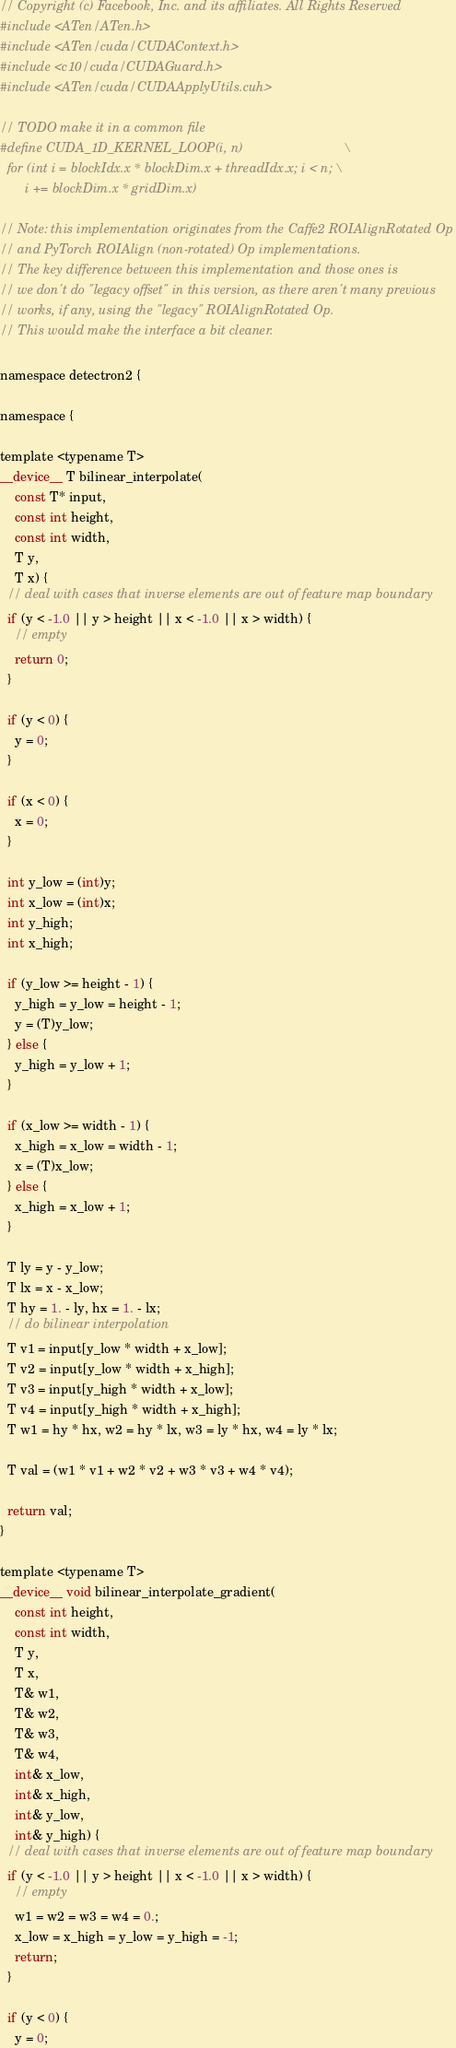Convert code to text. <code><loc_0><loc_0><loc_500><loc_500><_Cuda_>// Copyright (c) Facebook, Inc. and its affiliates. All Rights Reserved
#include <ATen/ATen.h>
#include <ATen/cuda/CUDAContext.h>
#include <c10/cuda/CUDAGuard.h>
#include <ATen/cuda/CUDAApplyUtils.cuh>

// TODO make it in a common file
#define CUDA_1D_KERNEL_LOOP(i, n)                            \
  for (int i = blockIdx.x * blockDim.x + threadIdx.x; i < n; \
       i += blockDim.x * gridDim.x)

// Note: this implementation originates from the Caffe2 ROIAlignRotated Op
// and PyTorch ROIAlign (non-rotated) Op implementations.
// The key difference between this implementation and those ones is
// we don't do "legacy offset" in this version, as there aren't many previous
// works, if any, using the "legacy" ROIAlignRotated Op.
// This would make the interface a bit cleaner.

namespace detectron2 {

namespace {

template <typename T>
__device__ T bilinear_interpolate(
    const T* input,
    const int height,
    const int width,
    T y,
    T x) {
  // deal with cases that inverse elements are out of feature map boundary
  if (y < -1.0 || y > height || x < -1.0 || x > width) {
    // empty
    return 0;
  }

  if (y < 0) {
    y = 0;
  }

  if (x < 0) {
    x = 0;
  }

  int y_low = (int)y;
  int x_low = (int)x;
  int y_high;
  int x_high;

  if (y_low >= height - 1) {
    y_high = y_low = height - 1;
    y = (T)y_low;
  } else {
    y_high = y_low + 1;
  }

  if (x_low >= width - 1) {
    x_high = x_low = width - 1;
    x = (T)x_low;
  } else {
    x_high = x_low + 1;
  }

  T ly = y - y_low;
  T lx = x - x_low;
  T hy = 1. - ly, hx = 1. - lx;
  // do bilinear interpolation
  T v1 = input[y_low * width + x_low];
  T v2 = input[y_low * width + x_high];
  T v3 = input[y_high * width + x_low];
  T v4 = input[y_high * width + x_high];
  T w1 = hy * hx, w2 = hy * lx, w3 = ly * hx, w4 = ly * lx;

  T val = (w1 * v1 + w2 * v2 + w3 * v3 + w4 * v4);

  return val;
}

template <typename T>
__device__ void bilinear_interpolate_gradient(
    const int height,
    const int width,
    T y,
    T x,
    T& w1,
    T& w2,
    T& w3,
    T& w4,
    int& x_low,
    int& x_high,
    int& y_low,
    int& y_high) {
  // deal with cases that inverse elements are out of feature map boundary
  if (y < -1.0 || y > height || x < -1.0 || x > width) {
    // empty
    w1 = w2 = w3 = w4 = 0.;
    x_low = x_high = y_low = y_high = -1;
    return;
  }

  if (y < 0) {
    y = 0;</code> 